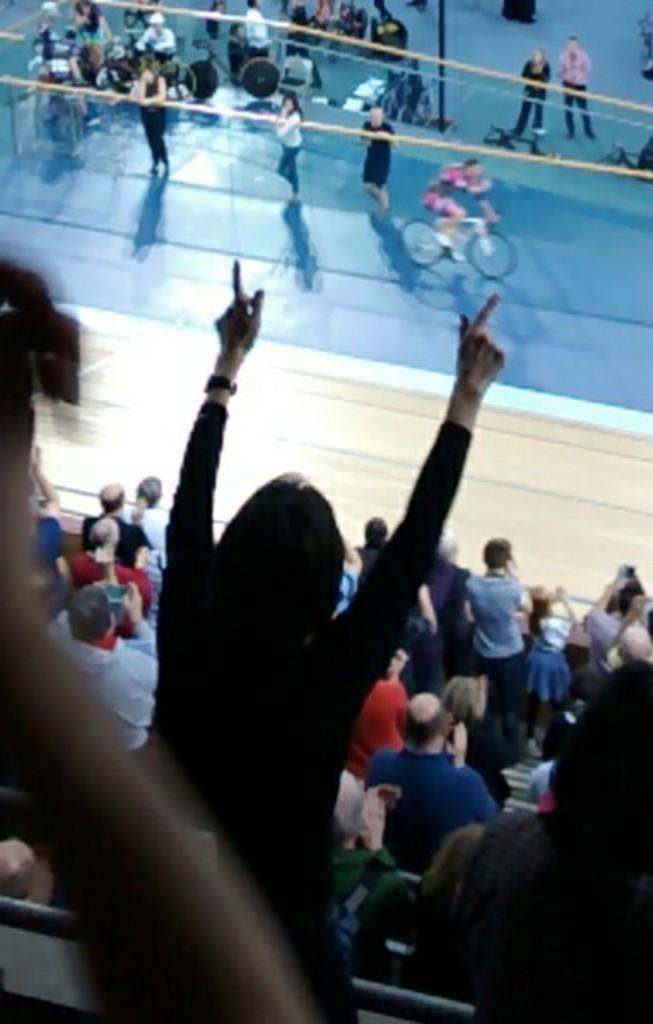In one or two sentences, can you explain what this image depicts? In this image I see number of people in front and in the background I see the blue color path and I see few cycles and few persons on it and I see few more people over here who are standing. 